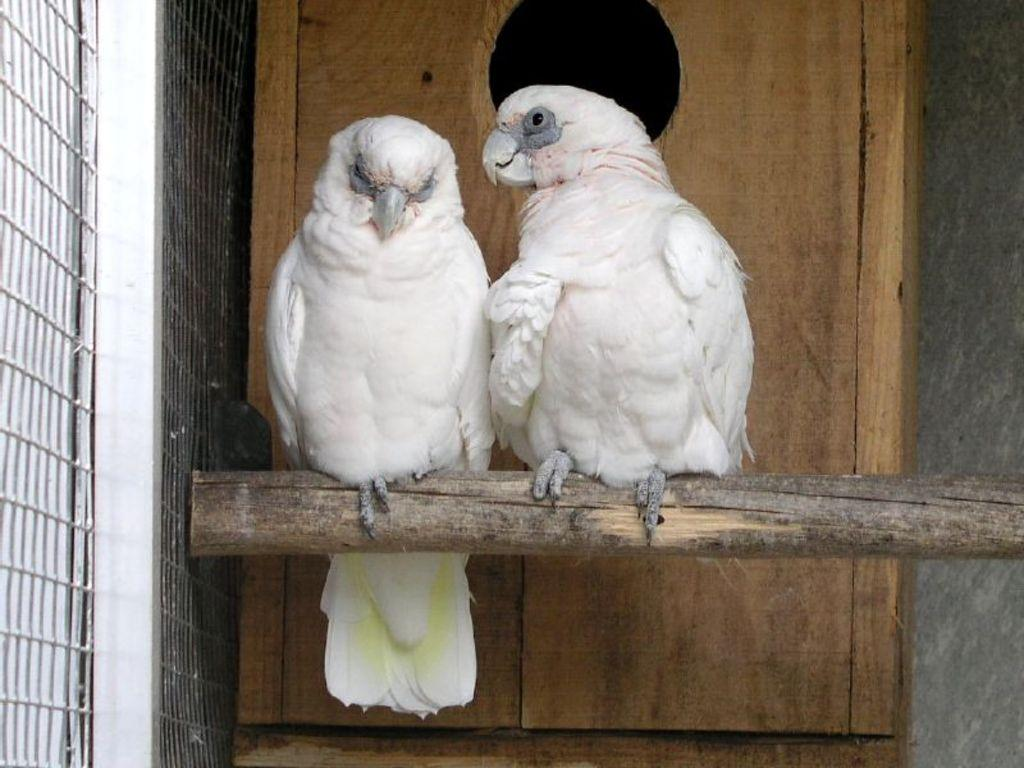How many birds are in the image? There are two birds in the image. What are the birds standing on? The birds are standing on a wooden trunk. What is visible on the left side of the image? There is a window on the left side of the image. What is the window attached to? The window is attached to a wall. What else is attached to the wall in the image? There is a wooden plank attached to the wall. What is the price of the sheet that the birds are using as a blanket? There is no sheet present in the image, and the birds are not using a blanket. 